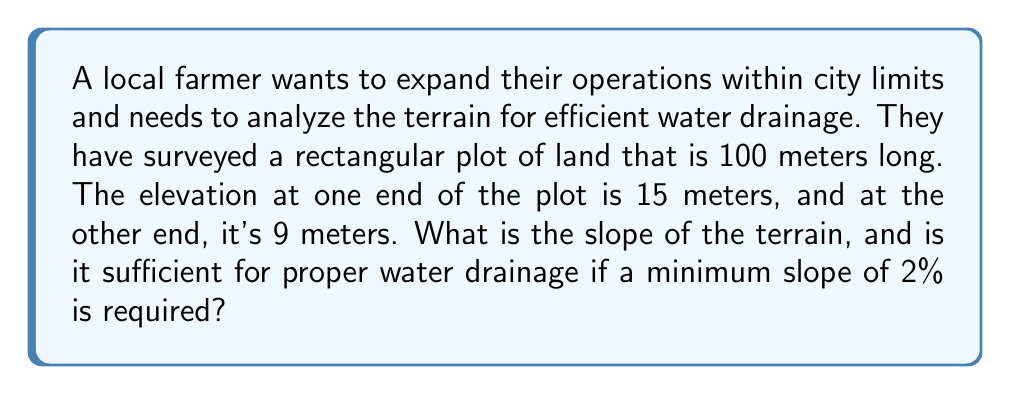Can you answer this question? Let's approach this step-by-step:

1) First, we need to calculate the slope of the terrain. The slope of a line is given by the formula:

   $$m = \frac{y_2 - y_1}{x_2 - x_1}$$

   where $(x_1, y_1)$ and $(x_2, y_2)$ are two points on the line.

2) In this case:
   - The horizontal distance (x) is 100 meters
   - The elevation at one end (y1) is 15 meters
   - The elevation at the other end (y2) is 9 meters

3) Plugging these values into the slope formula:

   $$m = \frac{9 - 15}{100 - 0} = \frac{-6}{100} = -0.06$$

4) The negative sign indicates that the elevation is decreasing along the length of the plot.

5) To express this as a percentage, we multiply by 100:

   $$-0.06 \times 100 = -6\%$$

6) The absolute value of this slope is 6%.

7) The question asks if this is sufficient for proper water drainage, given a minimum required slope of 2%.

8) Since 6% > 2%, the slope is indeed sufficient for proper water drainage.
Answer: The slope is -6% (or 6% downhill), which is sufficient for proper water drainage. 